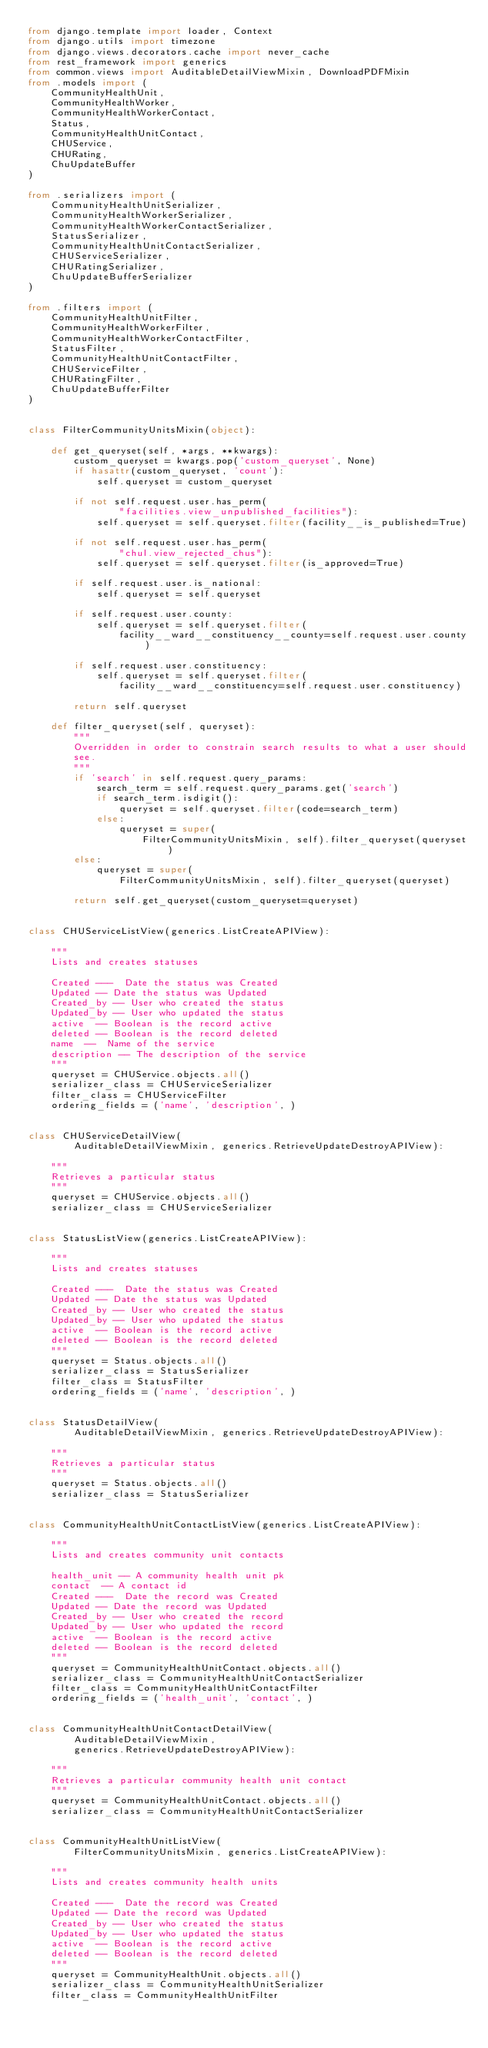Convert code to text. <code><loc_0><loc_0><loc_500><loc_500><_Python_>from django.template import loader, Context
from django.utils import timezone
from django.views.decorators.cache import never_cache
from rest_framework import generics
from common.views import AuditableDetailViewMixin, DownloadPDFMixin
from .models import (
    CommunityHealthUnit,
    CommunityHealthWorker,
    CommunityHealthWorkerContact,
    Status,
    CommunityHealthUnitContact,
    CHUService,
    CHURating,
    ChuUpdateBuffer
)

from .serializers import (
    CommunityHealthUnitSerializer,
    CommunityHealthWorkerSerializer,
    CommunityHealthWorkerContactSerializer,
    StatusSerializer,
    CommunityHealthUnitContactSerializer,
    CHUServiceSerializer,
    CHURatingSerializer,
    ChuUpdateBufferSerializer
)

from .filters import (
    CommunityHealthUnitFilter,
    CommunityHealthWorkerFilter,
    CommunityHealthWorkerContactFilter,
    StatusFilter,
    CommunityHealthUnitContactFilter,
    CHUServiceFilter,
    CHURatingFilter,
    ChuUpdateBufferFilter
)


class FilterCommunityUnitsMixin(object):

    def get_queryset(self, *args, **kwargs):
        custom_queryset = kwargs.pop('custom_queryset', None)
        if hasattr(custom_queryset, 'count'):
            self.queryset = custom_queryset

        if not self.request.user.has_perm(
                "facilities.view_unpublished_facilities"):
            self.queryset = self.queryset.filter(facility__is_published=True)

        if not self.request.user.has_perm(
                "chul.view_rejected_chus"):
            self.queryset = self.queryset.filter(is_approved=True)

        if self.request.user.is_national:
            self.queryset = self.queryset

        if self.request.user.county:
            self.queryset = self.queryset.filter(
                facility__ward__constituency__county=self.request.user.county)

        if self.request.user.constituency:
            self.queryset = self.queryset.filter(
                facility__ward__constituency=self.request.user.constituency)

        return self.queryset

    def filter_queryset(self, queryset):
        """
        Overridden in order to constrain search results to what a user should
        see.
        """
        if 'search' in self.request.query_params:
            search_term = self.request.query_params.get('search')
            if search_term.isdigit():
                queryset = self.queryset.filter(code=search_term)
            else:
                queryset = super(
                    FilterCommunityUnitsMixin, self).filter_queryset(queryset)
        else:
            queryset = super(
                FilterCommunityUnitsMixin, self).filter_queryset(queryset)

        return self.get_queryset(custom_queryset=queryset)


class CHUServiceListView(generics.ListCreateAPIView):

    """
    Lists and creates statuses

    Created ---  Date the status was Created
    Updated -- Date the status was Updated
    Created_by -- User who created the status
    Updated_by -- User who updated the status
    active  -- Boolean is the record active
    deleted -- Boolean is the record deleted
    name  --  Name of the service
    description -- The description of the service
    """
    queryset = CHUService.objects.all()
    serializer_class = CHUServiceSerializer
    filter_class = CHUServiceFilter
    ordering_fields = ('name', 'description', )


class CHUServiceDetailView(
        AuditableDetailViewMixin, generics.RetrieveUpdateDestroyAPIView):

    """
    Retrieves a particular status
    """
    queryset = CHUService.objects.all()
    serializer_class = CHUServiceSerializer


class StatusListView(generics.ListCreateAPIView):

    """
    Lists and creates statuses

    Created ---  Date the status was Created
    Updated -- Date the status was Updated
    Created_by -- User who created the status
    Updated_by -- User who updated the status
    active  -- Boolean is the record active
    deleted -- Boolean is the record deleted
    """
    queryset = Status.objects.all()
    serializer_class = StatusSerializer
    filter_class = StatusFilter
    ordering_fields = ('name', 'description', )


class StatusDetailView(
        AuditableDetailViewMixin, generics.RetrieveUpdateDestroyAPIView):

    """
    Retrieves a particular status
    """
    queryset = Status.objects.all()
    serializer_class = StatusSerializer


class CommunityHealthUnitContactListView(generics.ListCreateAPIView):

    """
    Lists and creates community unit contacts

    health_unit -- A community health unit pk
    contact  -- A contact id
    Created ---  Date the record was Created
    Updated -- Date the record was Updated
    Created_by -- User who created the record
    Updated_by -- User who updated the record
    active  -- Boolean is the record active
    deleted -- Boolean is the record deleted
    """
    queryset = CommunityHealthUnitContact.objects.all()
    serializer_class = CommunityHealthUnitContactSerializer
    filter_class = CommunityHealthUnitContactFilter
    ordering_fields = ('health_unit', 'contact', )


class CommunityHealthUnitContactDetailView(
        AuditableDetailViewMixin,
        generics.RetrieveUpdateDestroyAPIView):

    """
    Retrieves a particular community health unit contact
    """
    queryset = CommunityHealthUnitContact.objects.all()
    serializer_class = CommunityHealthUnitContactSerializer


class CommunityHealthUnitListView(
        FilterCommunityUnitsMixin, generics.ListCreateAPIView):

    """
    Lists and creates community health units

    Created ---  Date the record was Created
    Updated -- Date the record was Updated
    Created_by -- User who created the status
    Updated_by -- User who updated the status
    active  -- Boolean is the record active
    deleted -- Boolean is the record deleted
    """
    queryset = CommunityHealthUnit.objects.all()
    serializer_class = CommunityHealthUnitSerializer
    filter_class = CommunityHealthUnitFilter</code> 